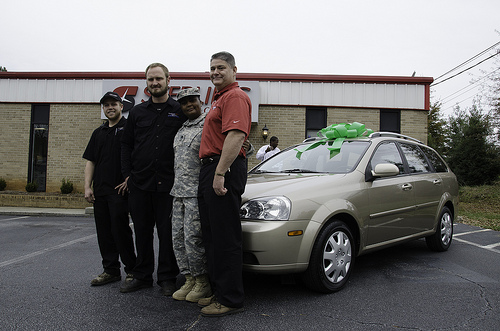<image>
Is the man in front of the car? Yes. The man is positioned in front of the car, appearing closer to the camera viewpoint. Is there a car in front of the man? No. The car is not in front of the man. The spatial positioning shows a different relationship between these objects. 